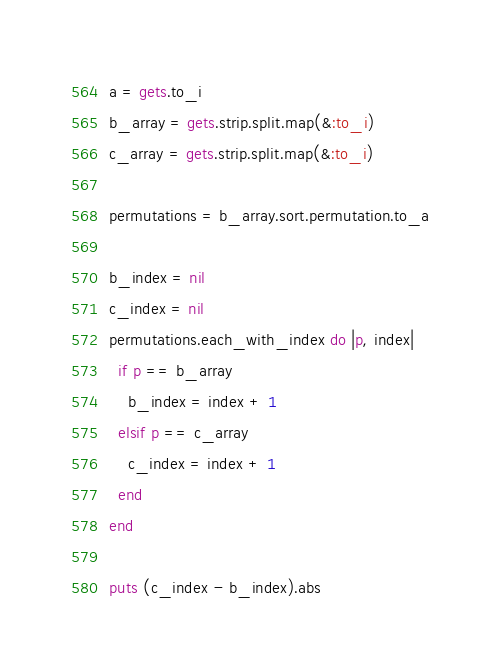Convert code to text. <code><loc_0><loc_0><loc_500><loc_500><_Ruby_>a = gets.to_i
b_array = gets.strip.split.map(&:to_i)
c_array = gets.strip.split.map(&:to_i)

permutations = b_array.sort.permutation.to_a

b_index = nil
c_index = nil
permutations.each_with_index do |p, index|
  if p == b_array
    b_index = index + 1
  elsif p == c_array
    c_index = index + 1
  end
end

puts (c_index - b_index).abs</code> 